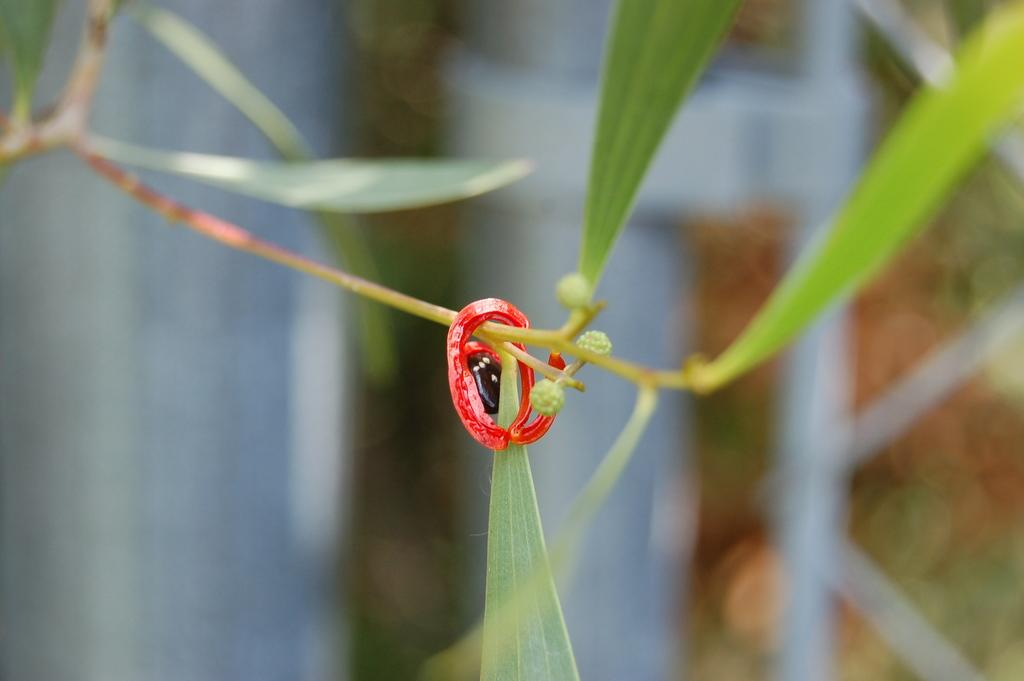What color is the object in the image? The object in the image is red. What is the object on in the image? The red object is on a stem. What else can be seen in the image besides the red object? There are leaves in the image. How would you describe the background of the image? The background of the image is blurred. What type of game is being played in the image? There is no game being played in the image; it features a red object on a stem with leaves and a blurred background. 